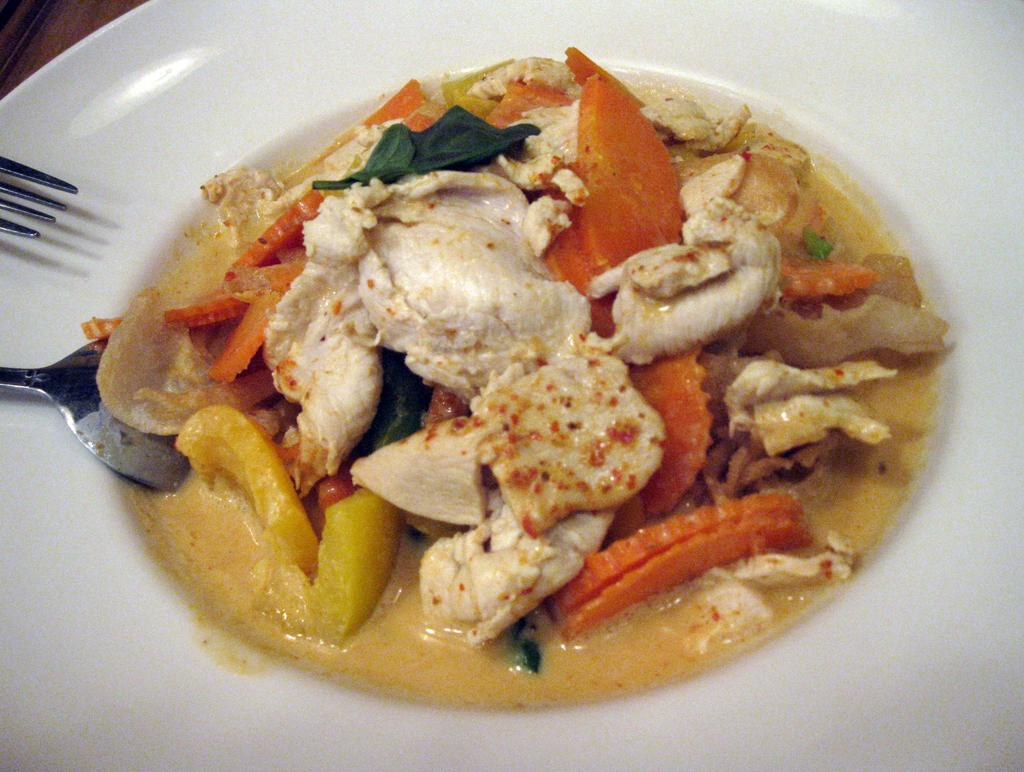What type of food can be seen in the image? There is food in the image, but the specific type is not mentioned. What colors are the food and the plate in the image? The food is in orange, white, and yellow colors, and the plate is white. What utensils are visible in the image? A spoon and a fork are visible on the left side of the image. What is the aftermath of the eggnog spill in the image? There is no mention of eggnog or any spill in the image, so it is not possible to describe an aftermath. 